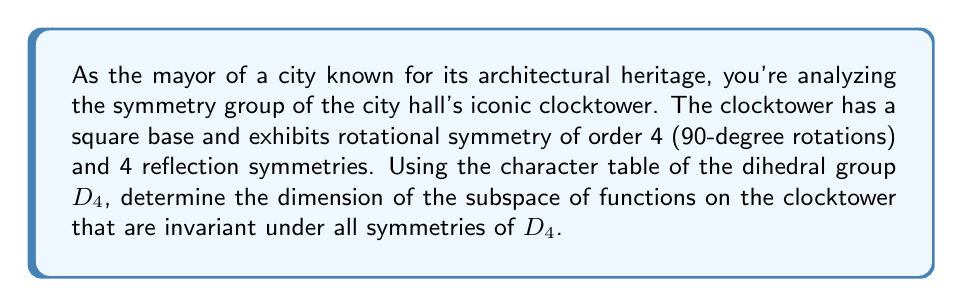Give your solution to this math problem. Let's approach this step-by-step:

1) The symmetry group of the clocktower is $D_4$, the dihedral group of order 8.

2) The character table for $D_4$ is:

   $$\begin{array}{c|ccccc}
      D_4 & E & C_4 & C_2 & C_2' & \sigma_v \\
      \hline
      \chi_1 & 1 & 1 & 1 & 1 & 1 \\
      \chi_2 & 1 & -1 & 1 & 1 & -1 \\
      \chi_3 & 1 & -1 & 1 & -1 & 1 \\
      \chi_4 & 1 & 1 & 1 & -1 & -1 \\
      \chi_5 & 2 & 0 & -2 & 0 & 0
   \end{array}$$

3) The regular representation $\rho$ of $D_4$ acting on functions on the clocktower has character:

   $$\chi_\rho = (8, 0, 0, 0, 0)$$

4) The dimension of the invariant subspace is given by the formula:

   $$\dim V^{D_4} = \frac{1}{|D_4|} \sum_{g \in D_4} \chi_\rho(g)$$

5) Applying this formula:

   $$\dim V^{D_4} = \frac{1}{8}(8 \cdot 1 + 2 \cdot 0 + 1 \cdot 0 + 2 \cdot 0 + 3 \cdot 0) = 1$$

6) Therefore, the dimension of the subspace of functions invariant under all symmetries of $D_4$ is 1.

This result indicates that only constant functions on the clocktower are invariant under all symmetries of $D_4$, which aligns with the idea of preserving the architectural integrity and symmetry of this landmark.
Answer: 1 